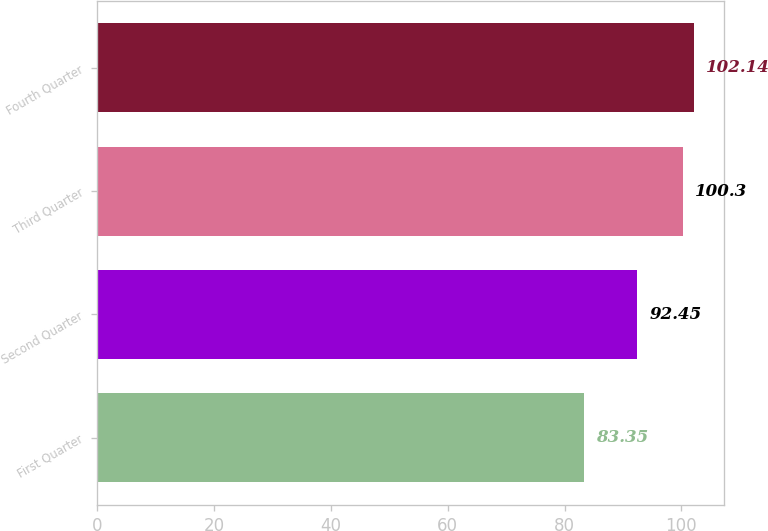Convert chart to OTSL. <chart><loc_0><loc_0><loc_500><loc_500><bar_chart><fcel>First Quarter<fcel>Second Quarter<fcel>Third Quarter<fcel>Fourth Quarter<nl><fcel>83.35<fcel>92.45<fcel>100.3<fcel>102.14<nl></chart> 